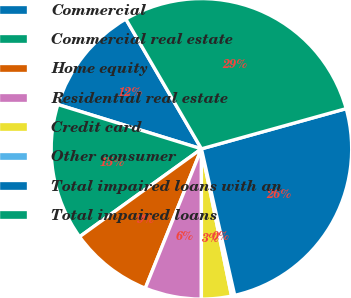<chart> <loc_0><loc_0><loc_500><loc_500><pie_chart><fcel>Commercial<fcel>Commercial real estate<fcel>Home equity<fcel>Residential real estate<fcel>Credit card<fcel>Other consumer<fcel>Total impaired loans with an<fcel>Total impaired loans<nl><fcel>11.84%<fcel>14.71%<fcel>8.96%<fcel>6.09%<fcel>3.22%<fcel>0.34%<fcel>25.76%<fcel>29.08%<nl></chart> 